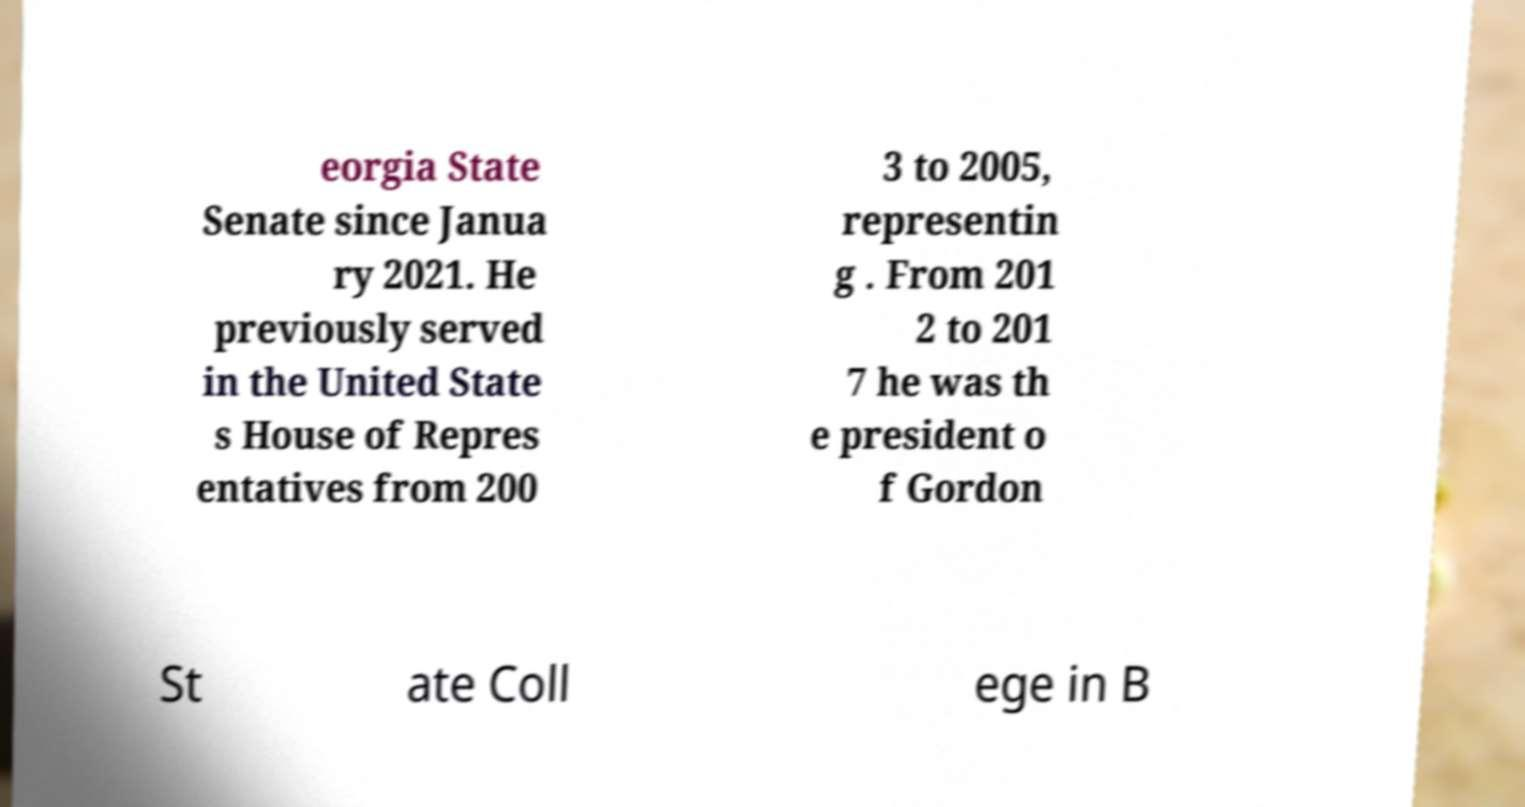Can you accurately transcribe the text from the provided image for me? eorgia State Senate since Janua ry 2021. He previously served in the United State s House of Repres entatives from 200 3 to 2005, representin g . From 201 2 to 201 7 he was th e president o f Gordon St ate Coll ege in B 